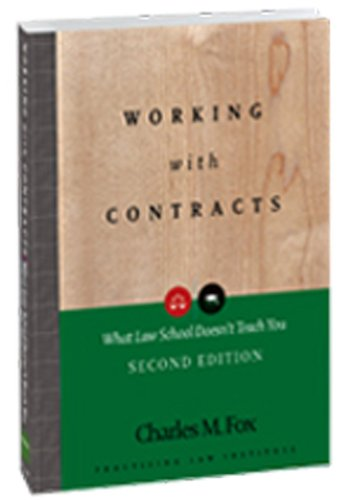What specific topics within contract law does this book cover? This book delves into practical aspects of contract law such as negotiating terms, understanding the implications of contract elements, and strategies for contract management and enforcement. 